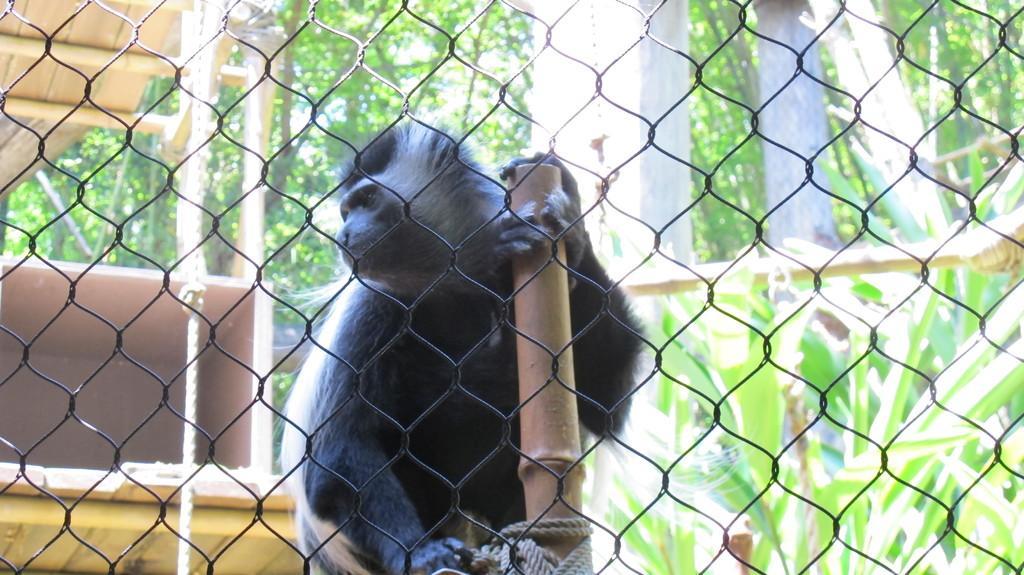Can you describe this image briefly? In this picture we can see a fence and behind the fence there is a bread of a monkey and a wooden pole. Behind the monkey there is a rope and trees. 